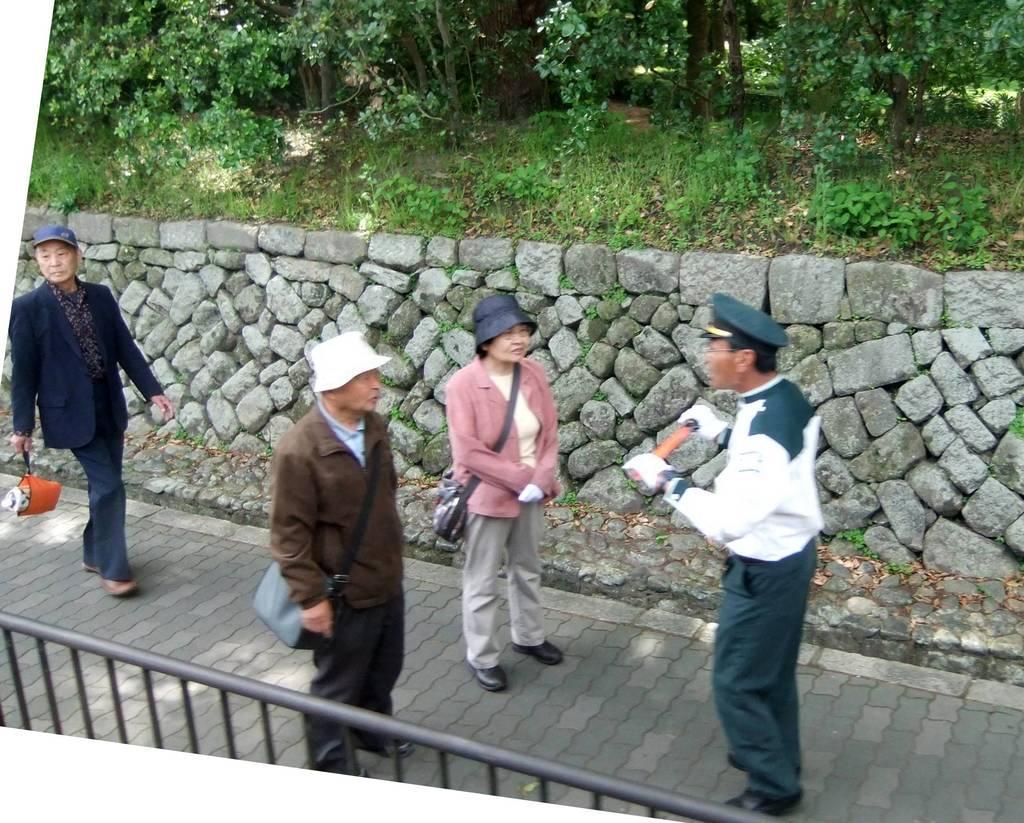Please provide a concise description of this image. There are three people standing and these two people wore bags and hats. This man walking and holding an object. We can see fence. In the background we can see wall,trees and plants. 